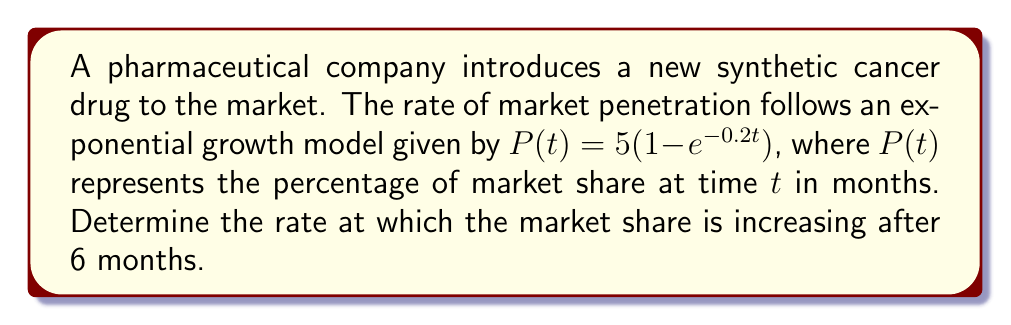Provide a solution to this math problem. To find the rate at which the market share is increasing after 6 months, we need to calculate the derivative of $P(t)$ and evaluate it at $t=6$. 

Step 1: Calculate the derivative of $P(t)$
$$\frac{d}{dt}P(t) = \frac{d}{dt}[5(1 - e^{-0.2t})]$$
$$\frac{d}{dt}P(t) = 5 \cdot \frac{d}{dt}[1 - e^{-0.2t}]$$
$$\frac{d}{dt}P(t) = 5 \cdot (-1) \cdot \frac{d}{dt}[e^{-0.2t}]$$
$$\frac{d}{dt}P(t) = 5 \cdot (-1) \cdot (-0.2) \cdot e^{-0.2t}$$
$$\frac{d}{dt}P(t) = e^{-0.2t}$$

Step 2: Evaluate the derivative at $t=6$
$$\frac{d}{dt}P(6) = e^{-0.2(6)}$$
$$\frac{d}{dt}P(6) = e^{-1.2}$$
$$\frac{d}{dt}P(6) \approx 0.3012$$

Therefore, after 6 months, the market share is increasing at a rate of approximately 0.3012% per month.
Answer: 0.3012% per month 